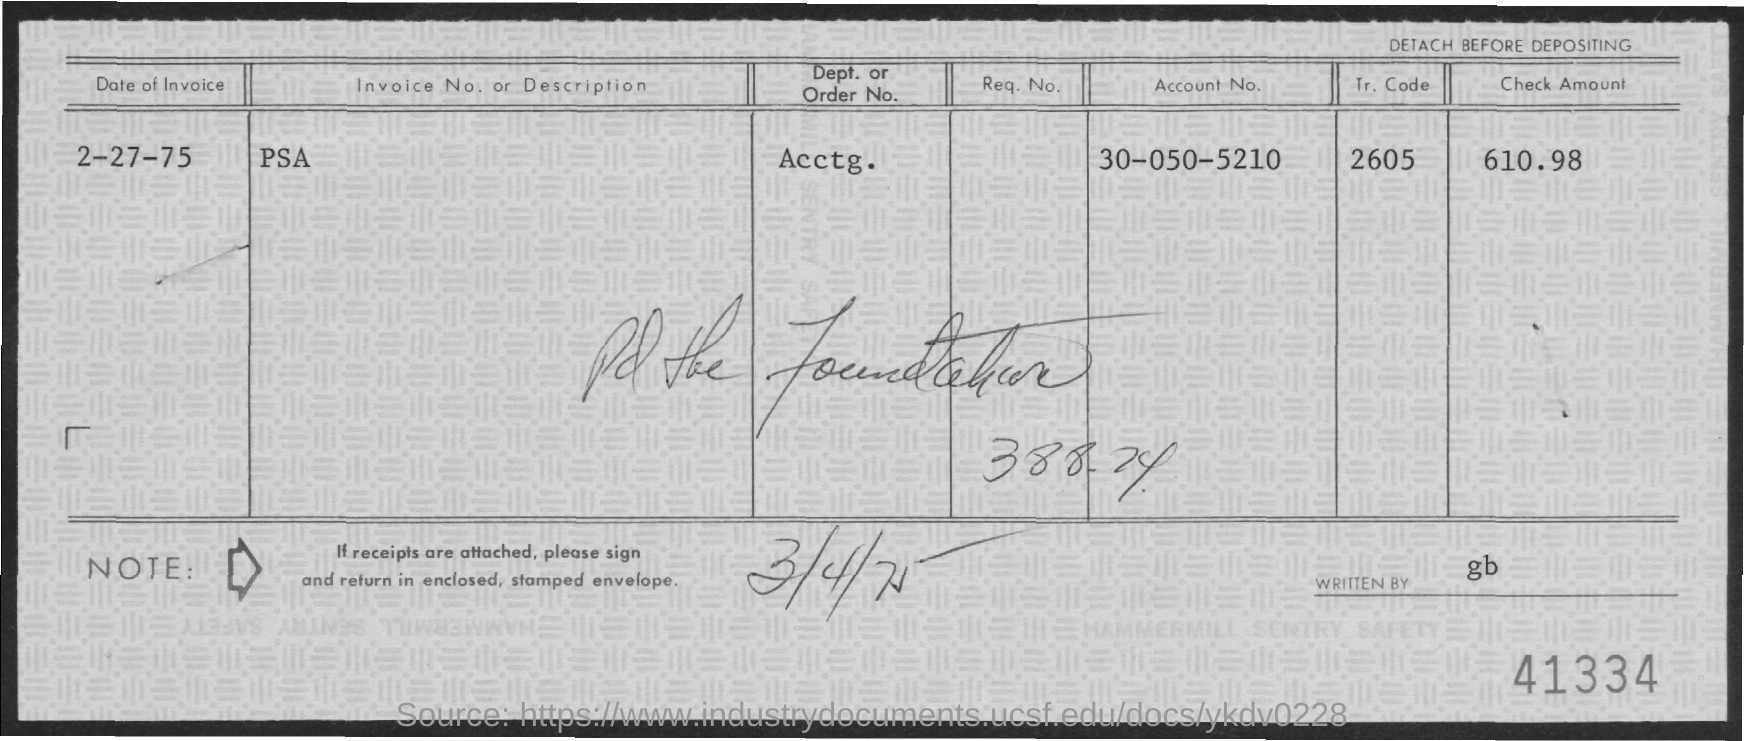Give some essential details in this illustration. The author of this text is unknown. I would like to know the amount of the check that I am holding, which is 610.98. Please provide the department or order number, as well as your accounting information, for our records. What is the Tr. Code? It is 2605. The account number is 30-050-5210. 